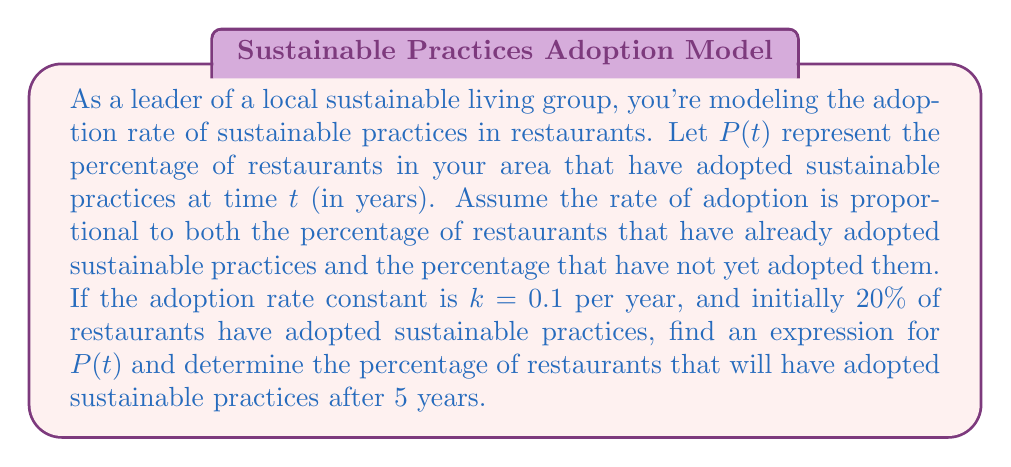Give your solution to this math problem. Let's approach this problem step-by-step:

1) The given information can be modeled using a logistic differential equation:

   $$\frac{dP}{dt} = kP(1-P)$$

   where $k = 0.1$ and $P(0) = 0.2$ (initial condition)

2) The solution to this logistic differential equation is:

   $$P(t) = \frac{1}{1 + Ce^{-kt}}$$

   where $C$ is a constant we need to determine.

3) To find $C$, we use the initial condition $P(0) = 0.2$:

   $$0.2 = \frac{1}{1 + C}$$

   Solving for $C$:
   $$C = \frac{1-0.2}{0.2} = 4$$

4) Now we have the complete solution:

   $$P(t) = \frac{1}{1 + 4e^{-0.1t}}$$

5) To find the percentage after 5 years, we evaluate $P(5)$:

   $$P(5) = \frac{1}{1 + 4e^{-0.1(5)}} = \frac{1}{1 + 4e^{-0.5}}$$

6) Calculating this value:

   $$P(5) \approx 0.3775 = 37.75\%$$
Answer: The expression for $P(t)$ is $$P(t) = \frac{1}{1 + 4e^{-0.1t}}$$
After 5 years, approximately 37.75% of restaurants will have adopted sustainable practices. 